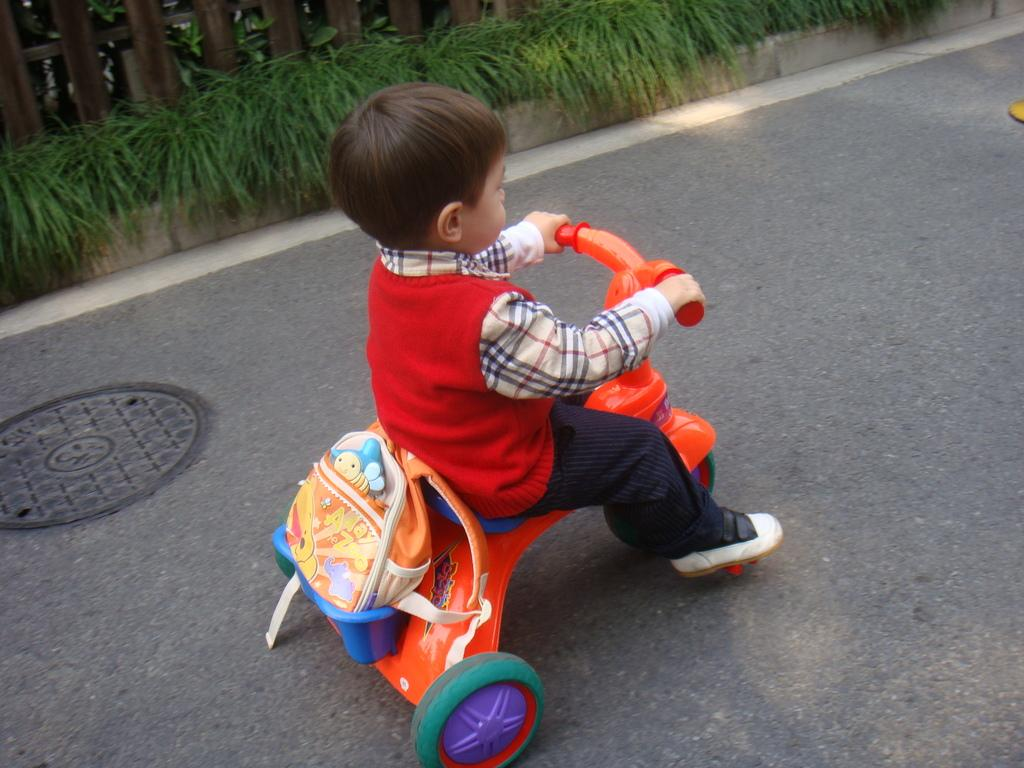Who is the main subject in the image? There is a boy in the image. What is the boy doing in the image? The boy is on a toy vehicle. What can be seen on the road in the image? There is a manhole lid on the road in the image. What type of vegetation is visible in the image? There are plants visible in the image. What architectural feature can be seen in the image? There is a fence in the image. What type of cattle can be seen grazing near the fence in the image? There are no cattle present in the image; it only features a boy on a toy vehicle, a manhole lid, plants, and a fence. 